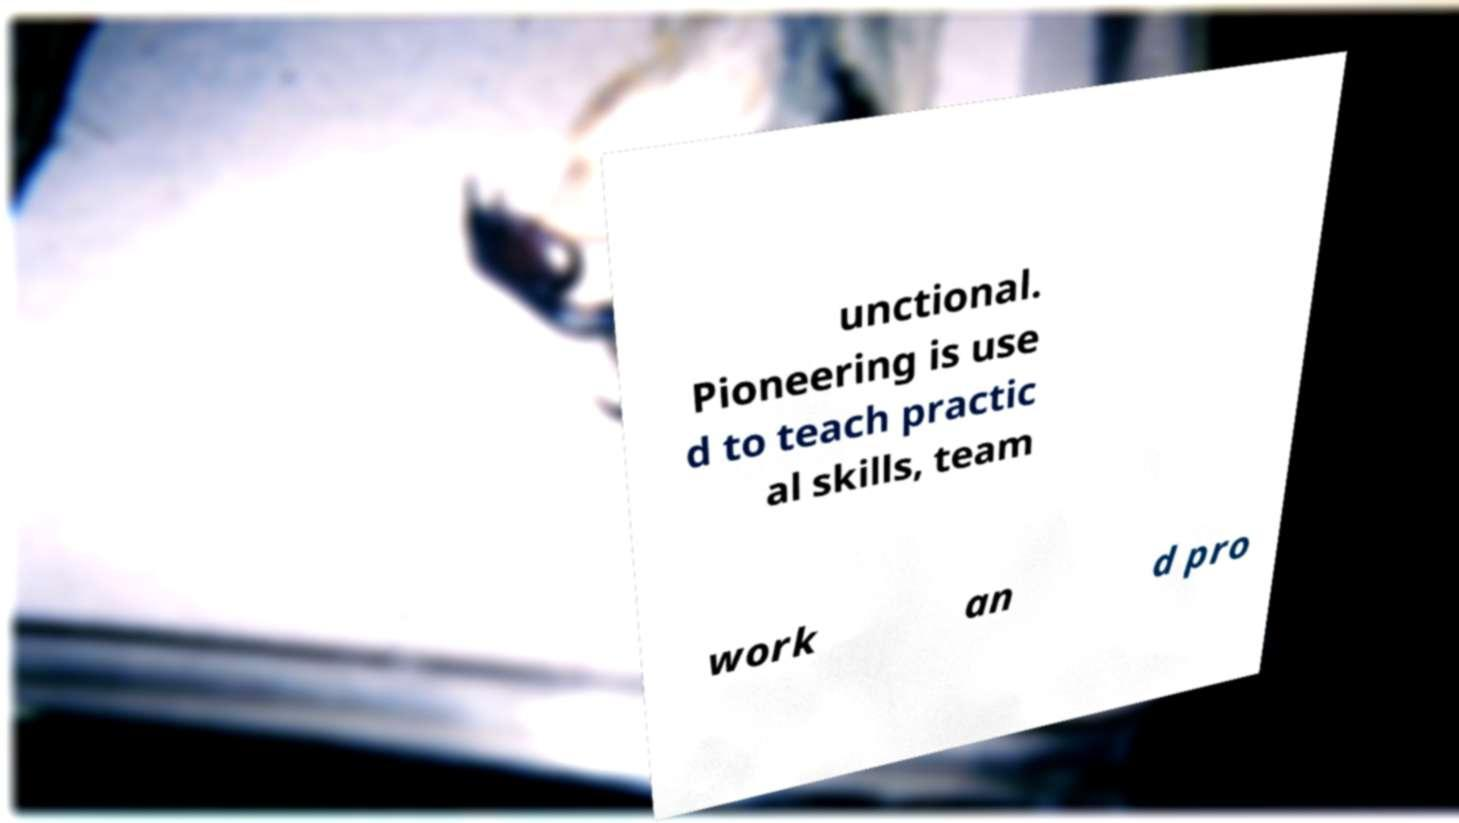Can you read and provide the text displayed in the image?This photo seems to have some interesting text. Can you extract and type it out for me? unctional. Pioneering is use d to teach practic al skills, team work an d pro 